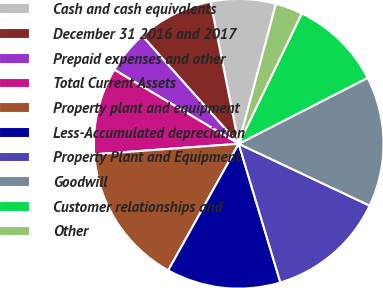Convert chart. <chart><loc_0><loc_0><loc_500><loc_500><pie_chart><fcel>Cash and cash equivalents<fcel>December 31 2016 and 2017<fcel>Prepaid expenses and other<fcel>Total Current Assets<fcel>Property plant and equipment<fcel>Less-Accumulated depreciation<fcel>Property Plant and Equipment<fcel>Goodwill<fcel>Customer relationships and<fcel>Other<nl><fcel>7.27%<fcel>8.48%<fcel>4.85%<fcel>9.7%<fcel>15.76%<fcel>12.73%<fcel>13.33%<fcel>14.55%<fcel>10.3%<fcel>3.03%<nl></chart> 